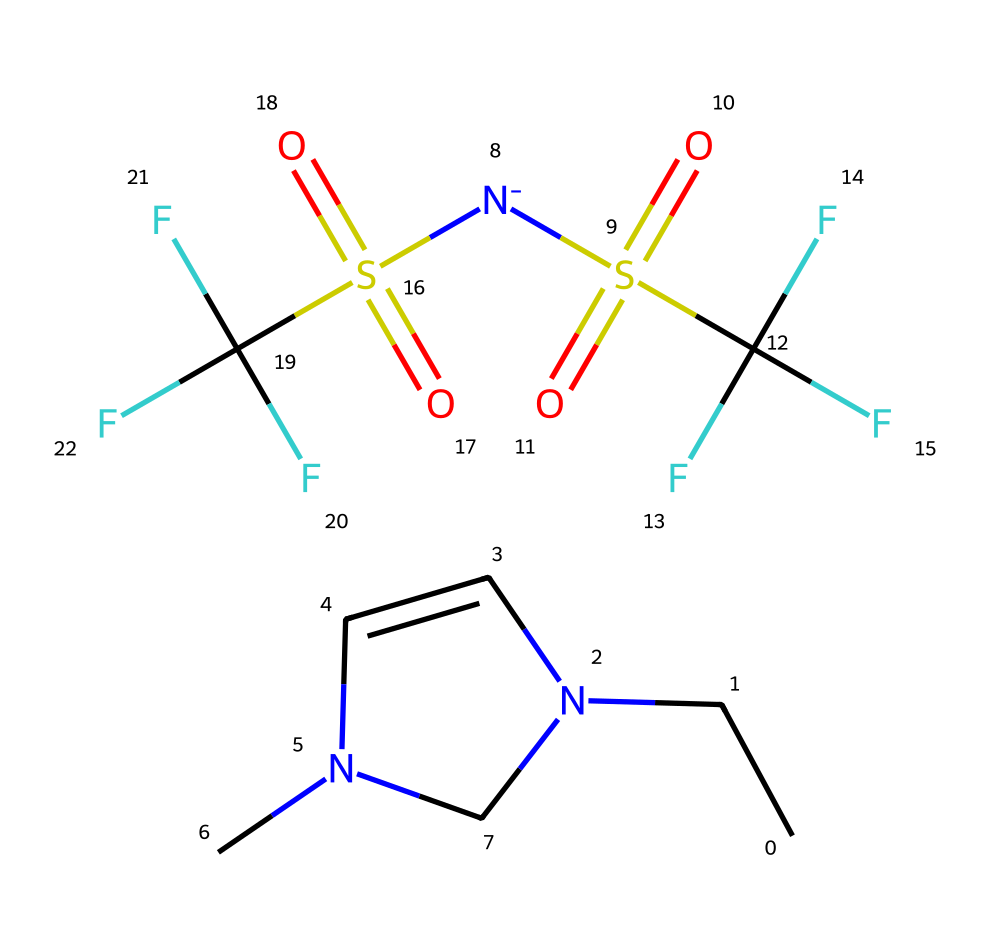What is the total number of atoms in this chemical? The SMILES representation consists of several elements, specifically carbon (C), nitrogen (N), oxygen (O), sulfur (S), and fluorine (F). By counting each type of atom represented in the SMILES, we find: 9 carbon (C), 3 nitrogen (N), 4 oxygen (O), 2 sulfur (S), and 3 fluorine (F). Adding these gives a total of 21 atoms.
Answer: 21 How many nitrogen atoms are present? From the SMILES notation, we can identify nitrogen atoms represented by the letter 'N'. There are three instances of 'N' in the chemical structure. Hence, the total number of nitrogen atoms is three.
Answer: 3 What is the major functional group present in this ionic liquid? The presence of the sulfonyl group, represented as 'S(=O)(=O)', indicates the presence of sulfonic groups, which are key in ionic liquids. The presence of two such groups is significant in defining the functionality of the ionic liquid.
Answer: sulfonate Does this ionic liquid have any fluorine atoms? The chemical structure displays the presence of fluorine atoms, denoted by 'F' in the SMILES representation. There are three instances of the 'F' character, confirming that fluorine is indeed present in this ionic liquid.
Answer: yes What is the significance of having a self-healing characteristic in ionic liquids? The self-healing characteristic comes from the molecular arrangement and interactions of the ionic liquid's components. It allows the material to recover from damage due to the dynamic exchange of ions, which helps maintain functionality. Therefore, ions can reorganize and 'heal' the material after stress or damage.
Answer: reorganization of ions What role do sulfonate groups play in the properties of ionic liquids? Sulfonate groups in ionic liquids enhance thermal stability and solubility of the ionic liquid. These groups also contribute to the ionic nature, affecting conductivity and viscosity, which are crucial for self-healing properties in electronic applications.
Answer: enhance conductivity and stability How does the arrangement of atoms influence the ionic liquid's electrochemical performance? The arrangement of atoms affects the mobility of ions within the ionic liquid. A well-organized structure promotes better ionic conduction, leading to improved electrochemical performance in applications like batteries and capacitors. Hence, a compact and effective arrangement can optimize ion transport.
Answer: improved ionic conduction 